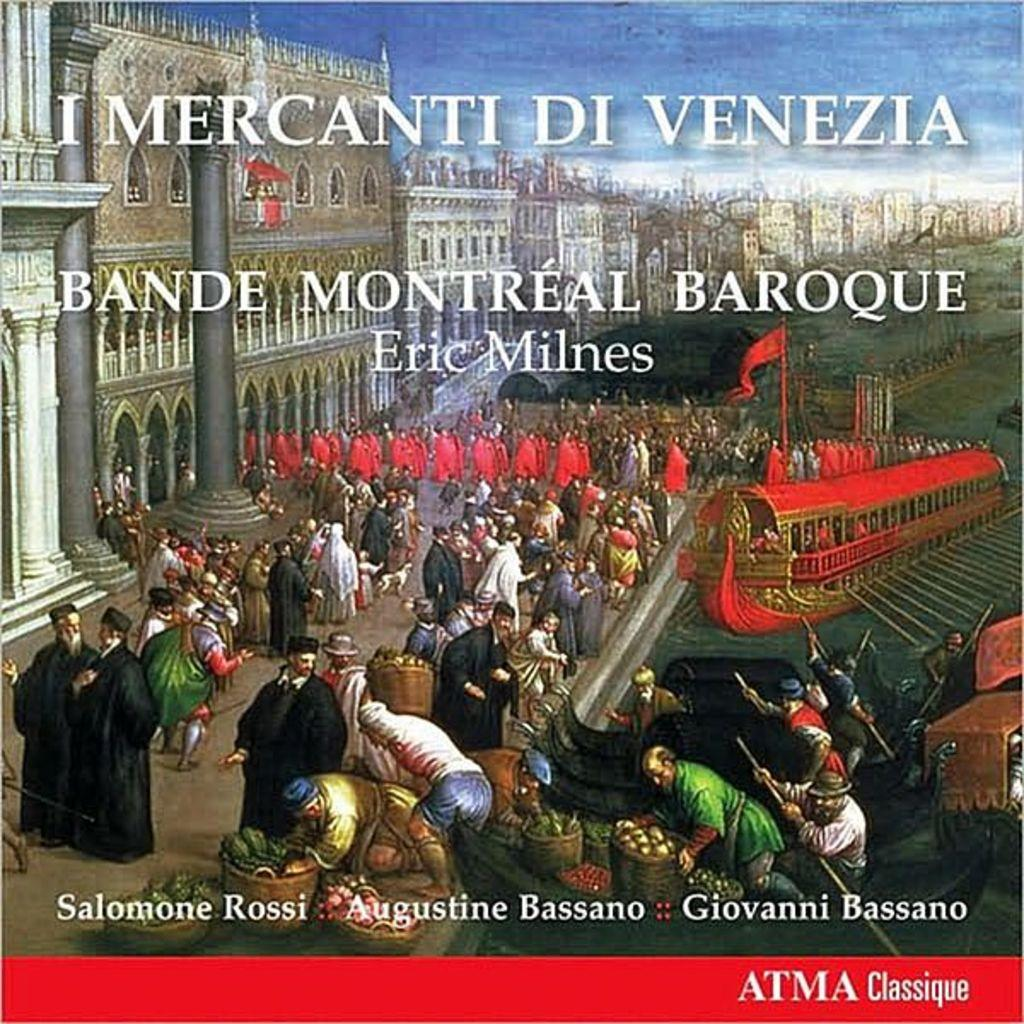Provide a one-sentence caption for the provided image. An historic book called I Mercanti DiVenezia which has three authors. 